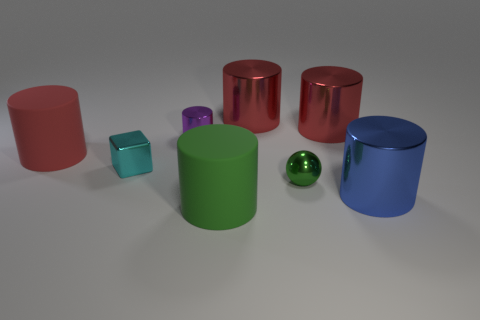Are the small object that is behind the red matte cylinder and the big thing left of the small shiny block made of the same material?
Make the answer very short. No. What is the color of the small cylinder?
Keep it short and to the point. Purple. There is a red shiny cylinder on the right side of the small metallic thing that is on the right side of the rubber cylinder to the right of the red matte thing; what size is it?
Offer a terse response. Large. What number of other objects are there of the same size as the cyan shiny block?
Offer a very short reply. 2. What number of big gray things are made of the same material as the purple thing?
Provide a succinct answer. 0. There is a rubber object to the left of the cyan metal object; what is its shape?
Keep it short and to the point. Cylinder. Does the ball have the same material as the thing that is to the left of the tiny block?
Offer a terse response. No. Are any small blue metallic spheres visible?
Keep it short and to the point. No. Are there any tiny metal objects behind the green object behind the big metallic cylinder in front of the cyan cube?
Give a very brief answer. Yes. What number of large things are brown cylinders or green metallic objects?
Your answer should be very brief. 0. 